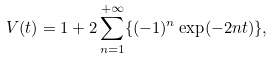Convert formula to latex. <formula><loc_0><loc_0><loc_500><loc_500>V ( t ) = 1 + 2 \sum _ { n = 1 } ^ { + \infty } \{ ( - 1 ) ^ { n } \exp ( - 2 n t ) \} ,</formula> 